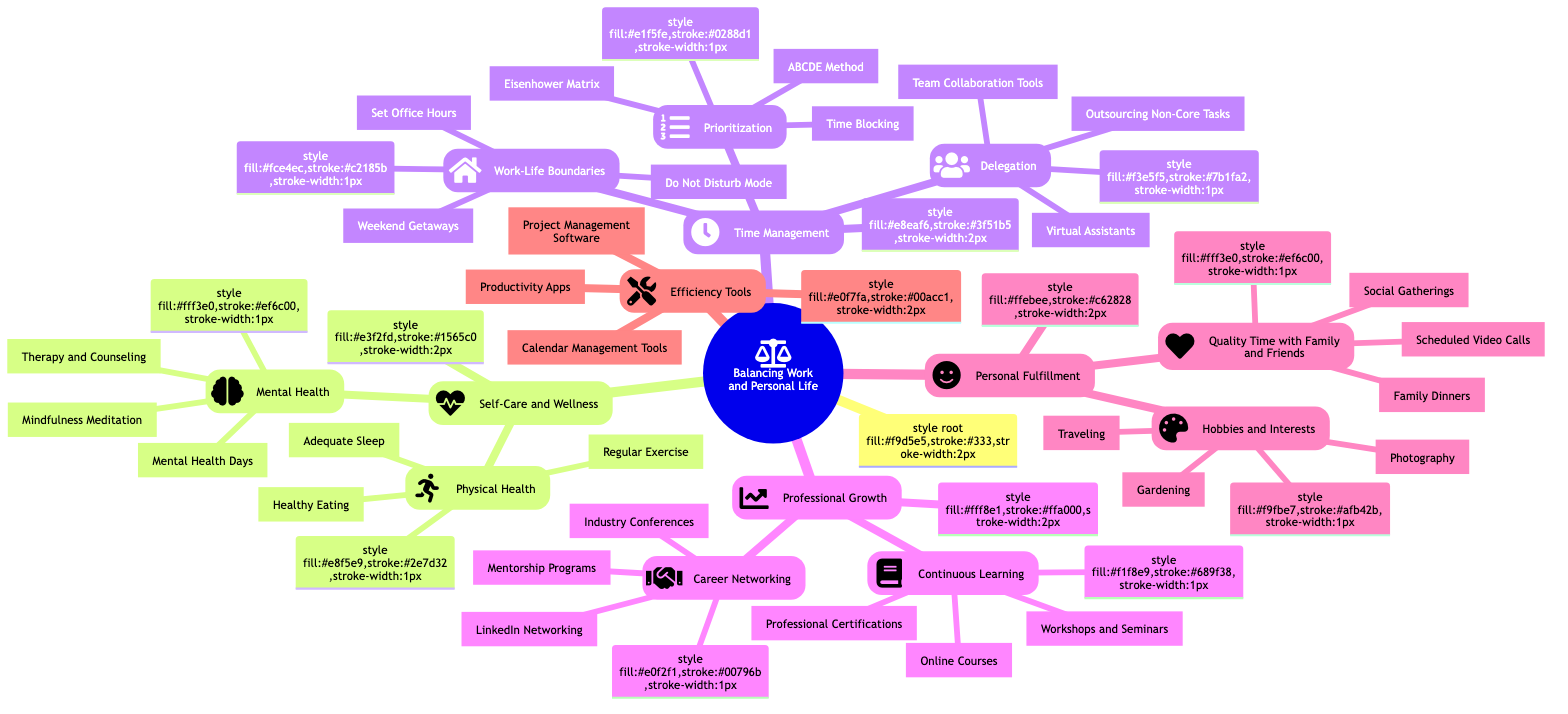What are the two main categories under "Self-Care and Wellness"? The diagram provides two subcategories under "Self-Care and Wellness," which are "Physical Health" and "Mental Health." Both are listed directly below this main category.
Answer: Physical Health and Mental Health How many strategies are listed under "Professional Growth"? The "Professional Growth" category contains two subcategories: "Continuous Learning" and "Career Networking." Each of these contains specific strategies, so there are a total of two main strategies listed in this section.
Answer: 2 Which technique is part of "Time Management" that helps in prioritization? The diagram details three techniques under "Prioritization," one of which is the "Eisenhower Matrix," directly mentioned in this list.
Answer: Eisenhower Matrix What type of tools are included in the "Efficiency Tools" category? The "Efficiency Tools" category lists three types of tools that improve productivity: "Productivity Apps," "Calendar Management Tools," and "Project Management Software." This indicates that various tool types are necessary for efficiency.
Answer: Productivity Apps, Calendar Management Tools, Project Management Software What is the common theme across the strategies listed in "Personal Fulfillment"? The strategies listed in "Personal Fulfillment" focus on enhancing life satisfaction and personal happiness. This category encompasses activities that nurture social connections and personal interests, such as hobbies and quality time with others.
Answer: Hobbies and Interests & Quality Time with Family and Friends How many total techniques are mentioned under "Time Management"? In the "Time Management" section, there are three subcategories: "Prioritization," "Delegation," and "Work-Life Boundaries." Each of these categories contains multiple techniques, totaling at least 8 specific techniques in this section alone.
Answer: 8 